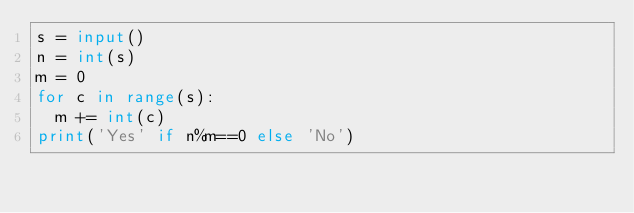Convert code to text. <code><loc_0><loc_0><loc_500><loc_500><_Python_>s = input()
n = int(s)
m = 0
for c in range(s):
  m += int(c)
print('Yes' if n%m==0 else 'No')</code> 